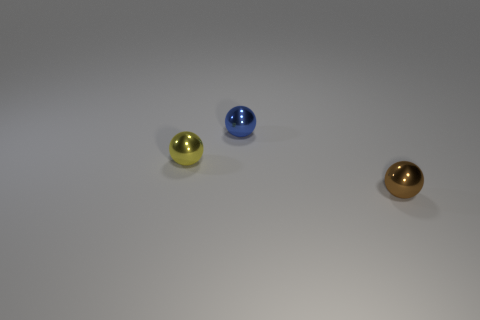What number of other objects are there of the same size as the brown sphere?
Your response must be concise. 2. There is a object behind the thing that is on the left side of the small blue shiny thing; how many balls are behind it?
Your response must be concise. 0. What is the material of the sphere that is on the right side of the tiny thing that is behind the small yellow object?
Offer a terse response. Metal. Are there any tiny red metal things that have the same shape as the brown shiny thing?
Make the answer very short. No. What number of things are either shiny balls that are in front of the blue metal ball or balls that are on the right side of the tiny yellow thing?
Ensure brevity in your answer.  3. How many objects are either blue metal objects or things?
Give a very brief answer. 3. There is a metallic object that is both to the right of the tiny yellow thing and behind the brown sphere; what size is it?
Your answer should be compact. Small. How many other tiny brown objects have the same material as the brown object?
Give a very brief answer. 0. There is a ball to the left of the tiny blue sphere; what material is it?
Your answer should be very brief. Metal. Are there an equal number of small brown balls that are behind the tiny brown thing and tiny blue metal objects?
Provide a short and direct response. No. 